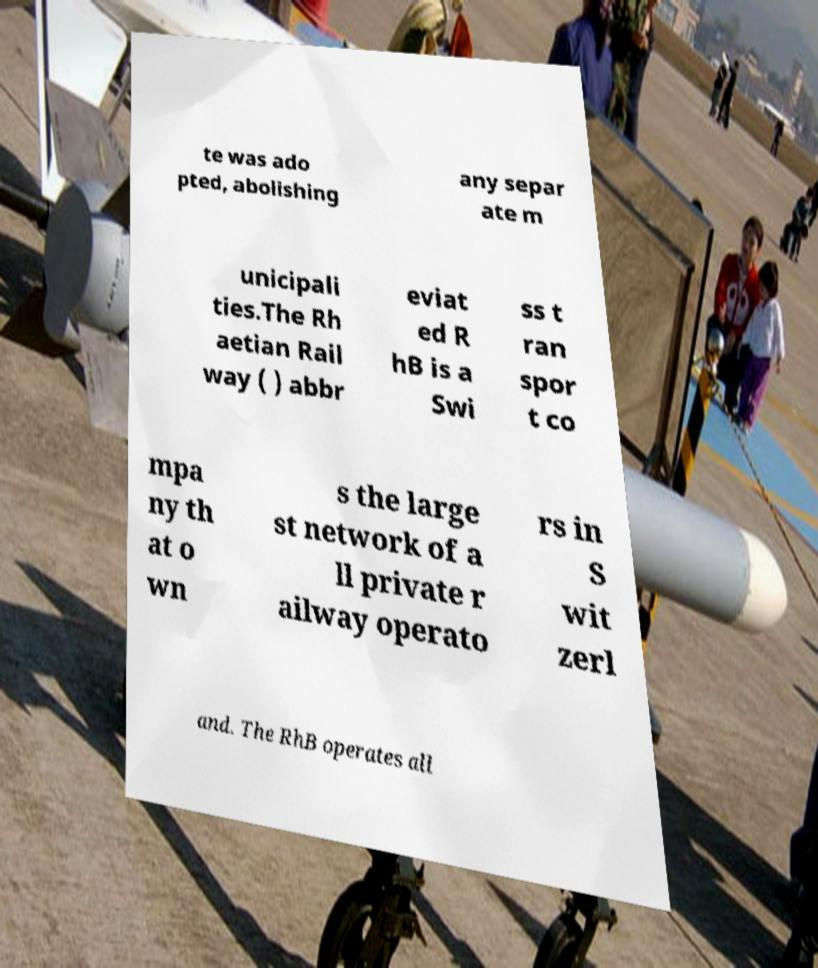I need the written content from this picture converted into text. Can you do that? te was ado pted, abolishing any separ ate m unicipali ties.The Rh aetian Rail way ( ) abbr eviat ed R hB is a Swi ss t ran spor t co mpa ny th at o wn s the large st network of a ll private r ailway operato rs in S wit zerl and. The RhB operates all 